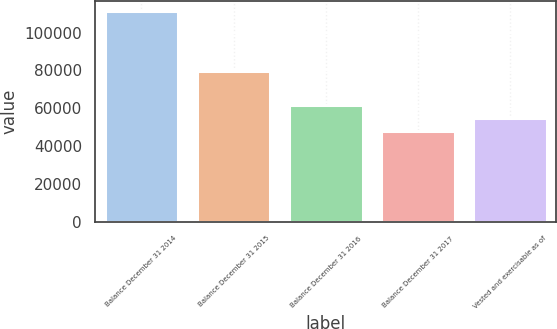Convert chart. <chart><loc_0><loc_0><loc_500><loc_500><bar_chart><fcel>Balance December 31 2014<fcel>Balance December 31 2015<fcel>Balance December 31 2016<fcel>Balance December 31 2017<fcel>Vested and exercisable as of<nl><fcel>111277<fcel>79474<fcel>61976.7<fcel>47890.9<fcel>54933.8<nl></chart> 